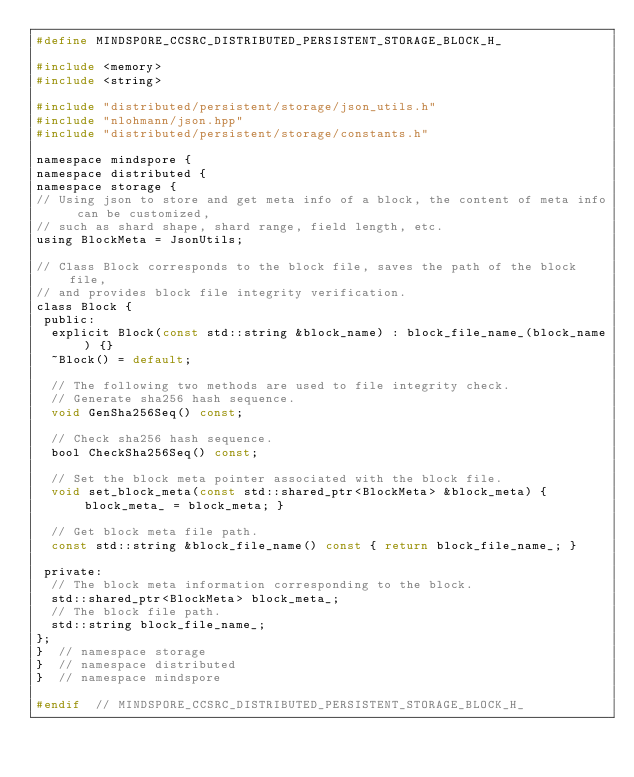<code> <loc_0><loc_0><loc_500><loc_500><_C_>#define MINDSPORE_CCSRC_DISTRIBUTED_PERSISTENT_STORAGE_BLOCK_H_

#include <memory>
#include <string>

#include "distributed/persistent/storage/json_utils.h"
#include "nlohmann/json.hpp"
#include "distributed/persistent/storage/constants.h"

namespace mindspore {
namespace distributed {
namespace storage {
// Using json to store and get meta info of a block, the content of meta info can be customized,
// such as shard shape, shard range, field length, etc.
using BlockMeta = JsonUtils;

// Class Block corresponds to the block file, saves the path of the block file,
// and provides block file integrity verification.
class Block {
 public:
  explicit Block(const std::string &block_name) : block_file_name_(block_name) {}
  ~Block() = default;

  // The following two methods are used to file integrity check.
  // Generate sha256 hash sequence.
  void GenSha256Seq() const;

  // Check sha256 hash sequence.
  bool CheckSha256Seq() const;

  // Set the block meta pointer associated with the block file.
  void set_block_meta(const std::shared_ptr<BlockMeta> &block_meta) { block_meta_ = block_meta; }

  // Get block meta file path.
  const std::string &block_file_name() const { return block_file_name_; }

 private:
  // The block meta information corresponding to the block.
  std::shared_ptr<BlockMeta> block_meta_;
  // The block file path.
  std::string block_file_name_;
};
}  // namespace storage
}  // namespace distributed
}  // namespace mindspore

#endif  // MINDSPORE_CCSRC_DISTRIBUTED_PERSISTENT_STORAGE_BLOCK_H_
</code> 